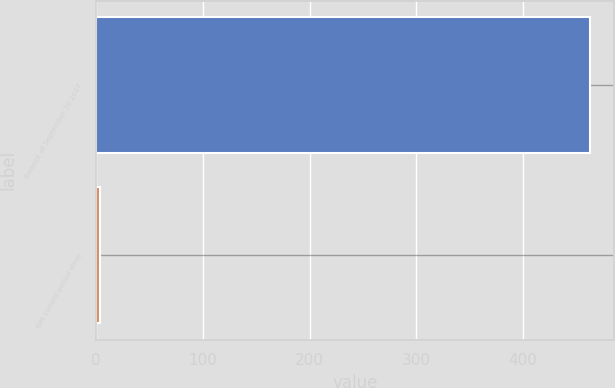<chart> <loc_0><loc_0><loc_500><loc_500><bar_chart><fcel>Balance at September 30 2017<fcel>Net current period other<nl><fcel>462.5<fcel>3.4<nl></chart> 